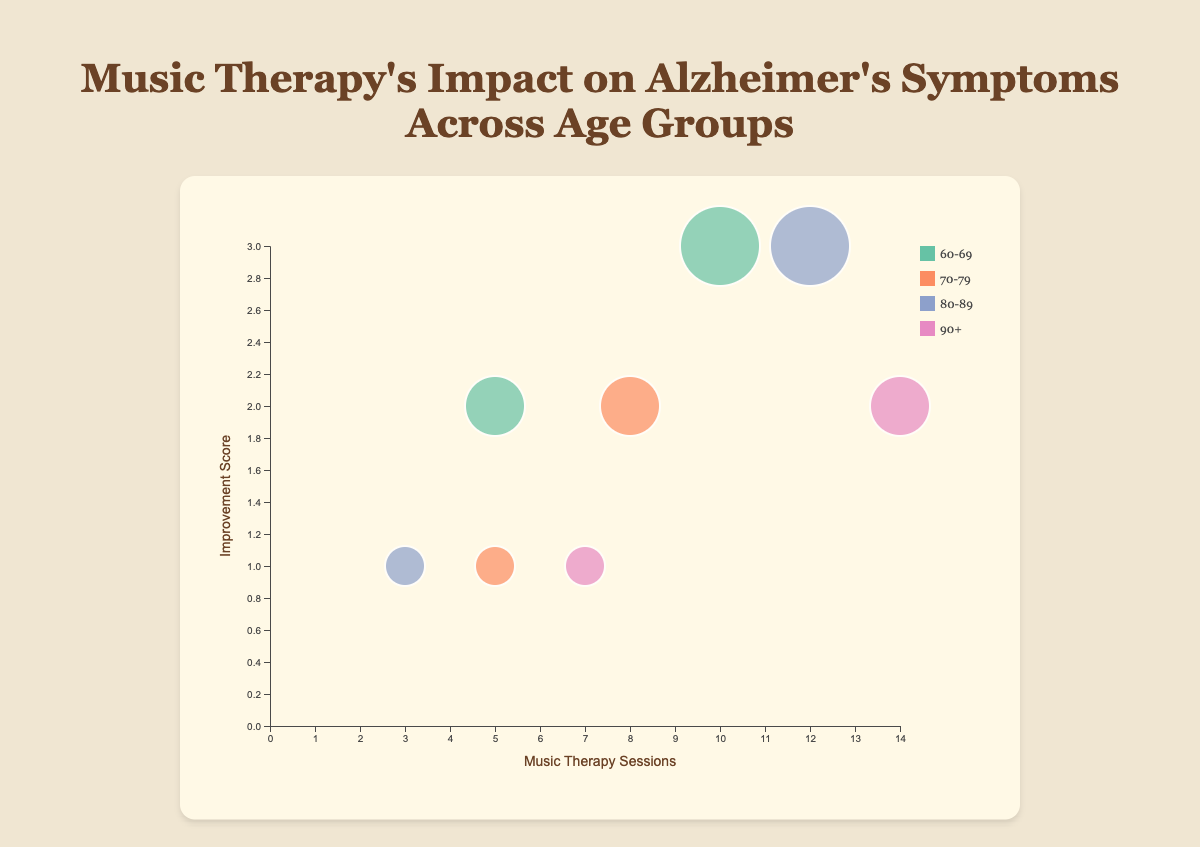What is the title of the chart? The title is located at the top of the chart in a bold and larger font size. It reads "Music Therapy's Impact on Alzheimer's Symptoms Across Age Groups".
Answer: Music Therapy's Impact on Alzheimer's Symptoms Across Age Groups How many unique age groups are represented in the data? The legend on the right side of the chart lists all the age groups represented by different colors. The legend shows four unique age groups: 60-69, 70-79, 80-89, and 90+.
Answer: 4 Which age group has the bubble with the highest number of music therapy sessions? The x-axis represents the number of music therapy sessions. Look for the bubble farthest to the right. This bubble is in the age group 90+, indicating they participated in 14 music therapy sessions.
Answer: 90+ For the age group 80-89, what is the improvement score when the number of music therapy sessions is 12? Locate the bubble where the x-axis (music therapy sessions) is 12 and the legend color for 80-89. The y-axis value of this bubble represents the improvement score, which is 3.
Answer: 3 Which symptom showed the most improvement in the 60-69 age group? Look at the bubbles colored for the 60-69 age group in the legend. Compare the y-axis (improvement score) of these bubbles. The bubble for Mood with an improvement score of 3 is the highest.
Answer: Mood What is the average improvement score for the 70-79 age group? Identify the bubbles for the 70-79 age group, noting their improvement scores. The scores are 1 and 2. Calculate the average: (1+2)/2 = 1.5
Answer: 1.5 Which age group has the highest improvement score for Memory Recall? Identify the bubbles labeled "Memory Recall" and check their age groups. The improvement scores are 2 for 70-79, 2 for 60-69, and 3 for 80-89. The highest is in the 80-89 age group.
Answer: 80-89 Do more therapy sessions correlate with higher improvement scores? Observing the bubbles' trends on the x (sessions) and y (improvement) axes indicates a general trend where higher sessions correlate with higher improvement scores, although not uniformly for all data points.
Answer: Yes, generally 